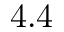Convert formula to latex. <formula><loc_0><loc_0><loc_500><loc_500>4 . 4</formula> 